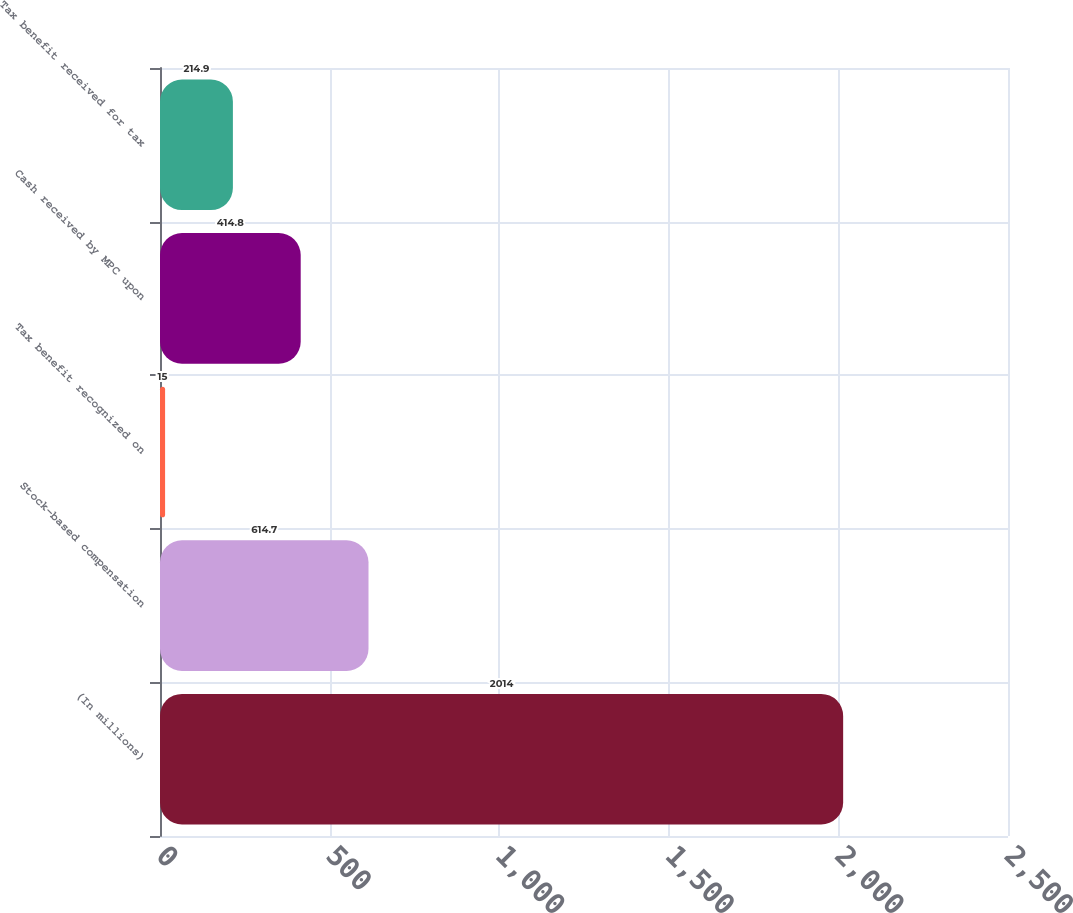Convert chart to OTSL. <chart><loc_0><loc_0><loc_500><loc_500><bar_chart><fcel>(In millions)<fcel>Stock-based compensation<fcel>Tax benefit recognized on<fcel>Cash received by MPC upon<fcel>Tax benefit received for tax<nl><fcel>2014<fcel>614.7<fcel>15<fcel>414.8<fcel>214.9<nl></chart> 